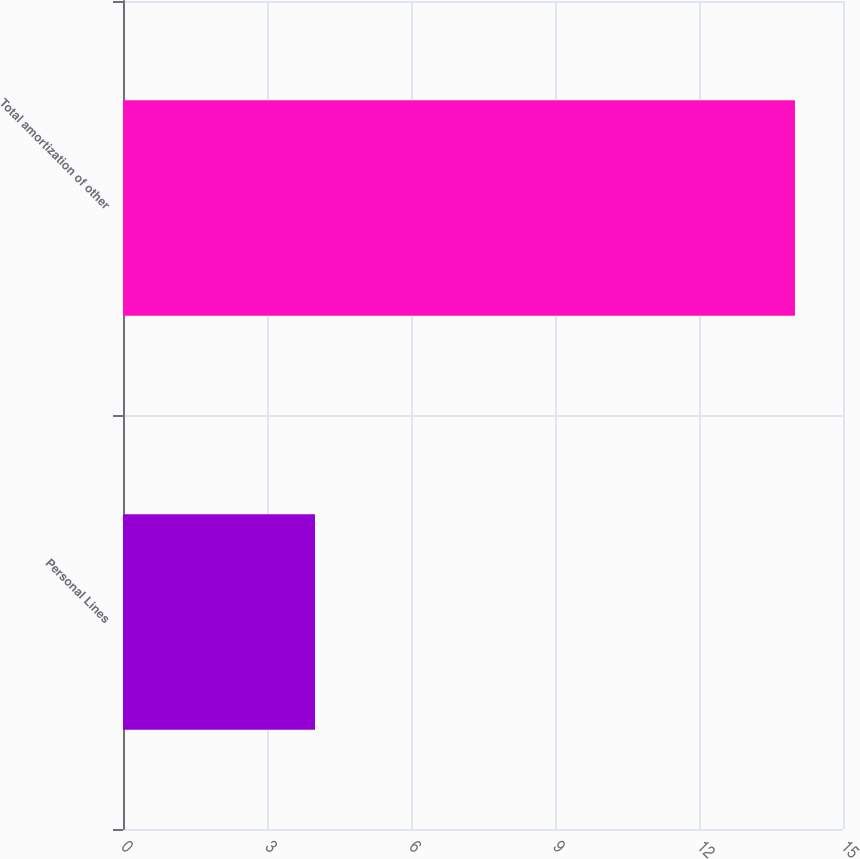Convert chart. <chart><loc_0><loc_0><loc_500><loc_500><bar_chart><fcel>Personal Lines<fcel>Total amortization of other<nl><fcel>4<fcel>14<nl></chart> 